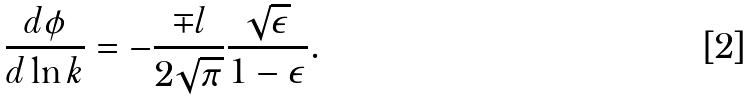Convert formula to latex. <formula><loc_0><loc_0><loc_500><loc_500>\frac { d \phi } { d \ln k } = - \frac { \mp l } { 2 \sqrt { \pi } } \frac { \sqrt { \epsilon } } { 1 - \epsilon } .</formula> 